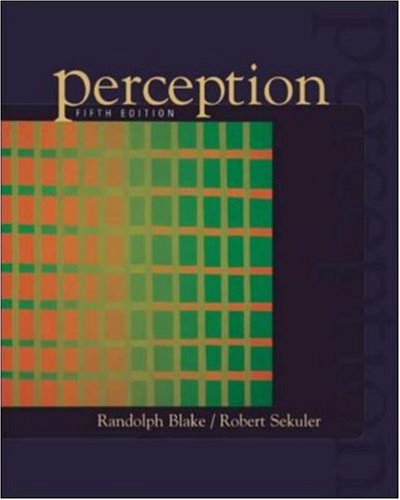What is the title of this book? The title of the book is 'Perception'. It's a comprehensive study on the mechanics and processes of visual perception. 